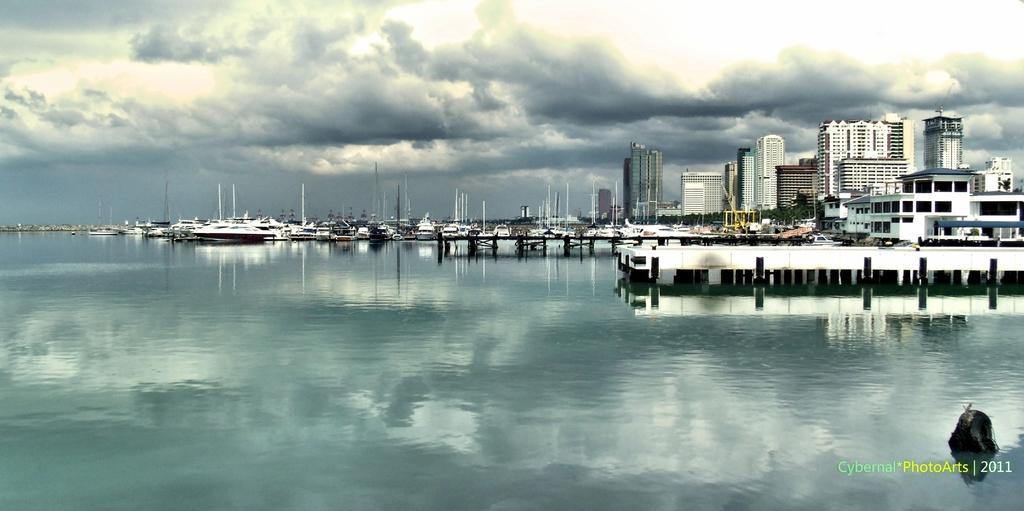In one or two sentences, can you explain what this image depicts? In this image there are ships in the water. In the background of the image there are buildings, trees and sky. There is some text on the right side of the image. 